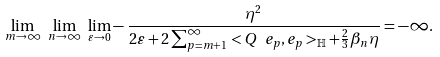Convert formula to latex. <formula><loc_0><loc_0><loc_500><loc_500>\underset { m \rightarrow \infty } { \lim } \ \underset { n \rightarrow \infty } { \lim } \ \underset { \varepsilon \rightarrow 0 } { \lim } - \frac { \eta ^ { 2 } } { 2 \varepsilon + 2 \sum _ { p = m + 1 } ^ { \infty } < Q \ e _ { p } , e _ { p } > _ { \mathbb { H } } + \frac { 2 } { 3 } \beta _ { n } \eta } = - \infty . \ \</formula> 